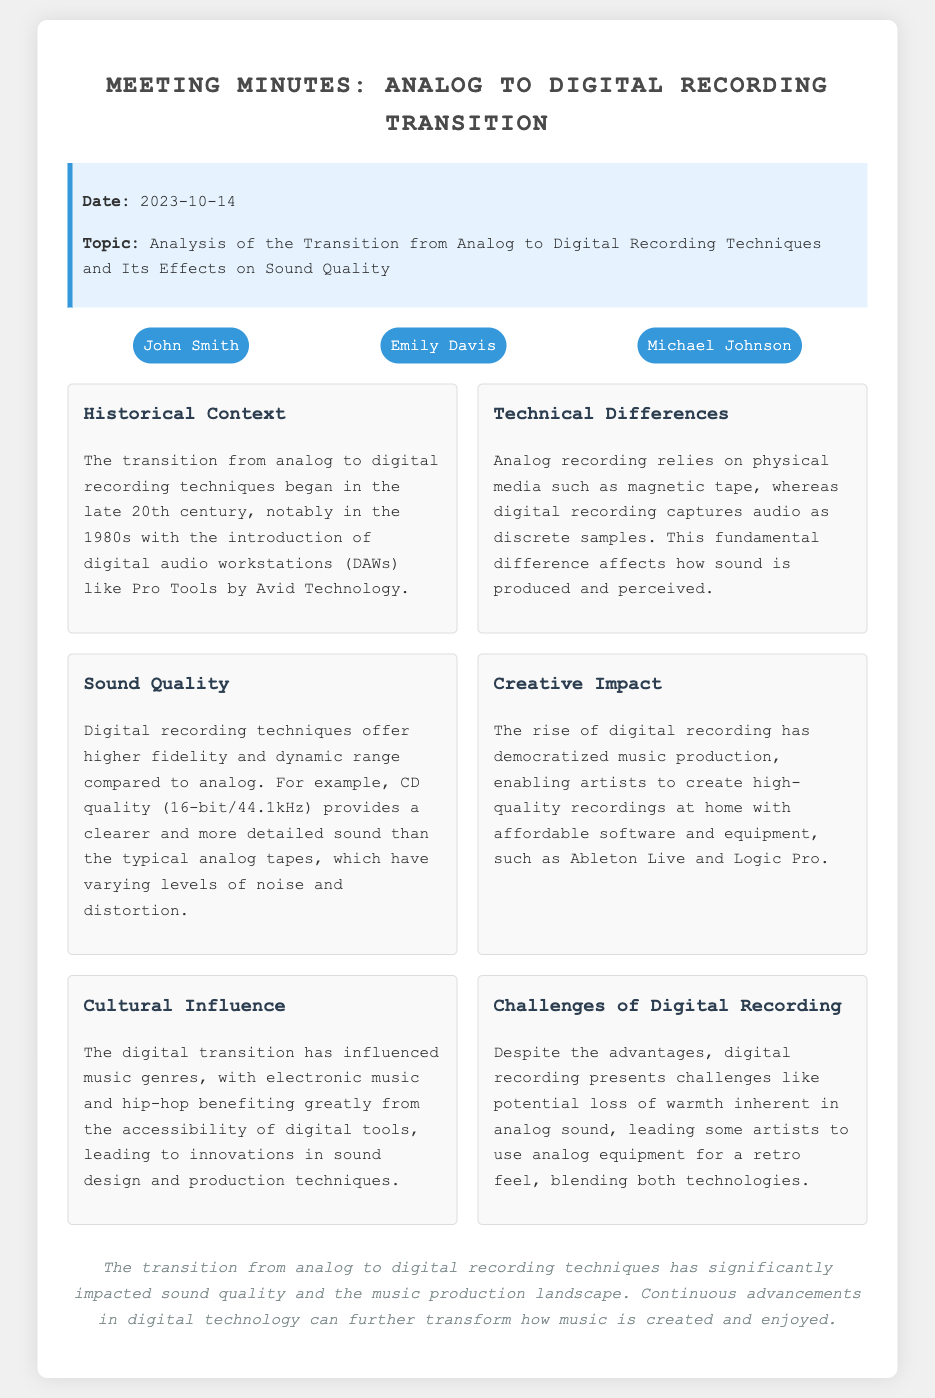What is the date of the meeting? The meeting date is presented in the document under the info section, stated clearly as 2023-10-14.
Answer: 2023-10-14 Who are the attendees? The attendees are listed in a section of the document, specifically John Smith, Emily Davis, and Michael Johnson.
Answer: John Smith, Emily Davis, Michael Johnson What was one of the key points discussed regarding sound quality? The document discusses that digital recording techniques offer higher fidelity and dynamic range, which is a change from analog recordings.
Answer: Higher fidelity and dynamic range What technology played a significant role in the digital transition? The text mentions that digital audio workstations like Pro Tools were significant in the transition from analog to digital recording.
Answer: Pro Tools What cultural influence has been noted from the digital transition? The document notes that the digital transition influenced genres like electronic music and hip-hop.
Answer: Electronic music and hip-hop What challenge of digital recording is mentioned? The document states that one challenge of digital recording is the potential loss of warmth inherent in analog sound.
Answer: Loss of warmth How has digital recording impacted music production? The notes state that digital recording has democratized music production, allowing artists to produce high-quality recordings from home.
Answer: Democratized music production What aspect did the meeting cover regarding the historical context? The meeting discussed that the transition began in the late 20th century, especially in the 1980s.
Answer: Late 20th century, 1980s 